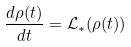<formula> <loc_0><loc_0><loc_500><loc_500>\frac { d \rho ( t ) } { d t } = { \mathcal { L } } _ { * } ( \rho ( t ) )</formula> 